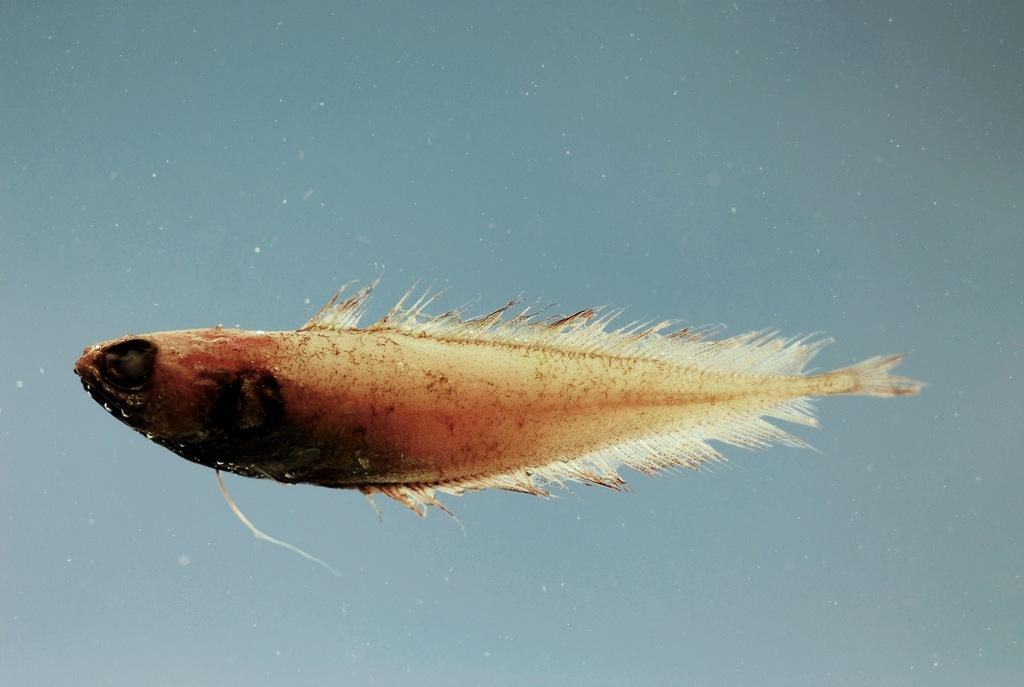What is the main subject of the image? The main subject of the image is a fish. Can you describe the location of the fish in the image? The fish is in the middle of the image. What else can be seen around the fish in the image? There are small, tiny particles around the fish. Can you tell me how many dolls are interacting with the carpenter in the image? There are no dolls or carpenters present in the image; it features a fish in the middle with small, tiny particles around it. How many lizards can be seen crawling on the fish in the image? There are no lizards present in the image; it features a fish in the middle with small, tiny particles around it. 